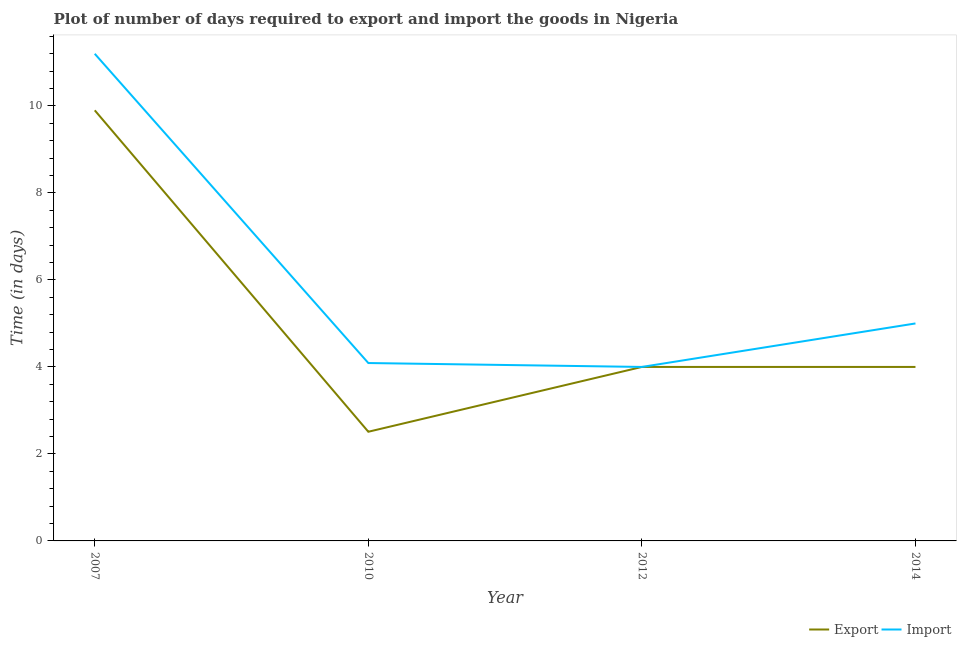How many different coloured lines are there?
Your answer should be very brief. 2. What is the time required to import in 2007?
Your answer should be very brief. 11.2. Across all years, what is the maximum time required to import?
Offer a terse response. 11.2. Across all years, what is the minimum time required to export?
Make the answer very short. 2.51. What is the total time required to import in the graph?
Your answer should be very brief. 24.29. What is the difference between the time required to import in 2010 and that in 2012?
Your answer should be very brief. 0.09. What is the difference between the time required to export in 2012 and the time required to import in 2007?
Ensure brevity in your answer.  -7.2. What is the average time required to import per year?
Offer a terse response. 6.07. In the year 2010, what is the difference between the time required to import and time required to export?
Your response must be concise. 1.58. What is the ratio of the time required to export in 2010 to that in 2014?
Provide a short and direct response. 0.63. Is the time required to export in 2007 less than that in 2012?
Keep it short and to the point. No. What is the difference between the highest and the second highest time required to import?
Offer a very short reply. 6.2. What is the difference between the highest and the lowest time required to import?
Offer a very short reply. 7.2. In how many years, is the time required to export greater than the average time required to export taken over all years?
Make the answer very short. 1. Is the sum of the time required to export in 2007 and 2012 greater than the maximum time required to import across all years?
Your answer should be very brief. Yes. Is the time required to export strictly greater than the time required to import over the years?
Keep it short and to the point. No. Is the time required to export strictly less than the time required to import over the years?
Your response must be concise. No. What is the difference between two consecutive major ticks on the Y-axis?
Provide a succinct answer. 2. Are the values on the major ticks of Y-axis written in scientific E-notation?
Give a very brief answer. No. How many legend labels are there?
Offer a terse response. 2. What is the title of the graph?
Make the answer very short. Plot of number of days required to export and import the goods in Nigeria. Does "Automatic Teller Machines" appear as one of the legend labels in the graph?
Provide a succinct answer. No. What is the label or title of the Y-axis?
Provide a short and direct response. Time (in days). What is the Time (in days) of Export in 2007?
Your answer should be very brief. 9.9. What is the Time (in days) in Export in 2010?
Ensure brevity in your answer.  2.51. What is the Time (in days) in Import in 2010?
Make the answer very short. 4.09. What is the Time (in days) in Export in 2012?
Make the answer very short. 4. What is the Time (in days) in Export in 2014?
Offer a very short reply. 4. Across all years, what is the maximum Time (in days) in Export?
Your answer should be very brief. 9.9. Across all years, what is the maximum Time (in days) in Import?
Your answer should be compact. 11.2. Across all years, what is the minimum Time (in days) of Export?
Your answer should be compact. 2.51. What is the total Time (in days) in Export in the graph?
Make the answer very short. 20.41. What is the total Time (in days) in Import in the graph?
Offer a terse response. 24.29. What is the difference between the Time (in days) of Export in 2007 and that in 2010?
Keep it short and to the point. 7.39. What is the difference between the Time (in days) of Import in 2007 and that in 2010?
Your answer should be very brief. 7.11. What is the difference between the Time (in days) in Import in 2007 and that in 2012?
Your answer should be compact. 7.2. What is the difference between the Time (in days) in Import in 2007 and that in 2014?
Ensure brevity in your answer.  6.2. What is the difference between the Time (in days) of Export in 2010 and that in 2012?
Your answer should be very brief. -1.49. What is the difference between the Time (in days) in Import in 2010 and that in 2012?
Ensure brevity in your answer.  0.09. What is the difference between the Time (in days) in Export in 2010 and that in 2014?
Provide a succinct answer. -1.49. What is the difference between the Time (in days) of Import in 2010 and that in 2014?
Your response must be concise. -0.91. What is the difference between the Time (in days) in Import in 2012 and that in 2014?
Provide a succinct answer. -1. What is the difference between the Time (in days) in Export in 2007 and the Time (in days) in Import in 2010?
Provide a succinct answer. 5.81. What is the difference between the Time (in days) of Export in 2007 and the Time (in days) of Import in 2012?
Your response must be concise. 5.9. What is the difference between the Time (in days) in Export in 2010 and the Time (in days) in Import in 2012?
Your answer should be compact. -1.49. What is the difference between the Time (in days) in Export in 2010 and the Time (in days) in Import in 2014?
Your answer should be compact. -2.49. What is the difference between the Time (in days) of Export in 2012 and the Time (in days) of Import in 2014?
Offer a very short reply. -1. What is the average Time (in days) in Export per year?
Ensure brevity in your answer.  5.1. What is the average Time (in days) of Import per year?
Your answer should be very brief. 6.07. In the year 2007, what is the difference between the Time (in days) of Export and Time (in days) of Import?
Give a very brief answer. -1.3. In the year 2010, what is the difference between the Time (in days) of Export and Time (in days) of Import?
Keep it short and to the point. -1.58. What is the ratio of the Time (in days) of Export in 2007 to that in 2010?
Your answer should be compact. 3.94. What is the ratio of the Time (in days) of Import in 2007 to that in 2010?
Your response must be concise. 2.74. What is the ratio of the Time (in days) in Export in 2007 to that in 2012?
Offer a very short reply. 2.48. What is the ratio of the Time (in days) of Import in 2007 to that in 2012?
Make the answer very short. 2.8. What is the ratio of the Time (in days) in Export in 2007 to that in 2014?
Your answer should be compact. 2.48. What is the ratio of the Time (in days) in Import in 2007 to that in 2014?
Ensure brevity in your answer.  2.24. What is the ratio of the Time (in days) of Export in 2010 to that in 2012?
Provide a succinct answer. 0.63. What is the ratio of the Time (in days) in Import in 2010 to that in 2012?
Your answer should be very brief. 1.02. What is the ratio of the Time (in days) of Export in 2010 to that in 2014?
Provide a succinct answer. 0.63. What is the ratio of the Time (in days) in Import in 2010 to that in 2014?
Make the answer very short. 0.82. What is the ratio of the Time (in days) of Export in 2012 to that in 2014?
Provide a succinct answer. 1. What is the difference between the highest and the lowest Time (in days) in Export?
Make the answer very short. 7.39. 